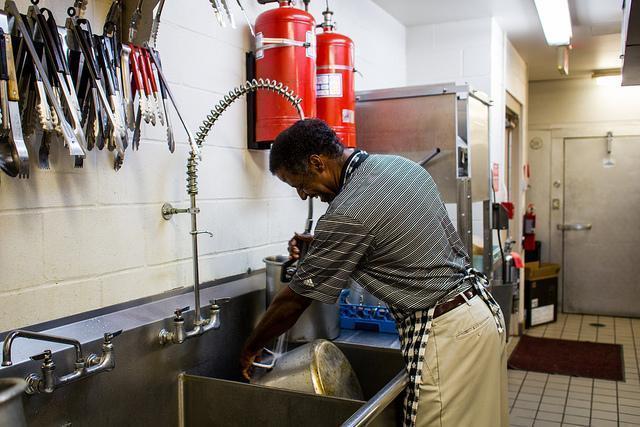What items are hanging on the wall?
Indicate the correct response and explain using: 'Answer: answer
Rationale: rationale.'
Options: Family crests, portraits, posters, tongs. Answer: tongs.
Rationale: Several metal pinchers are hanging above a man washing dishes. 